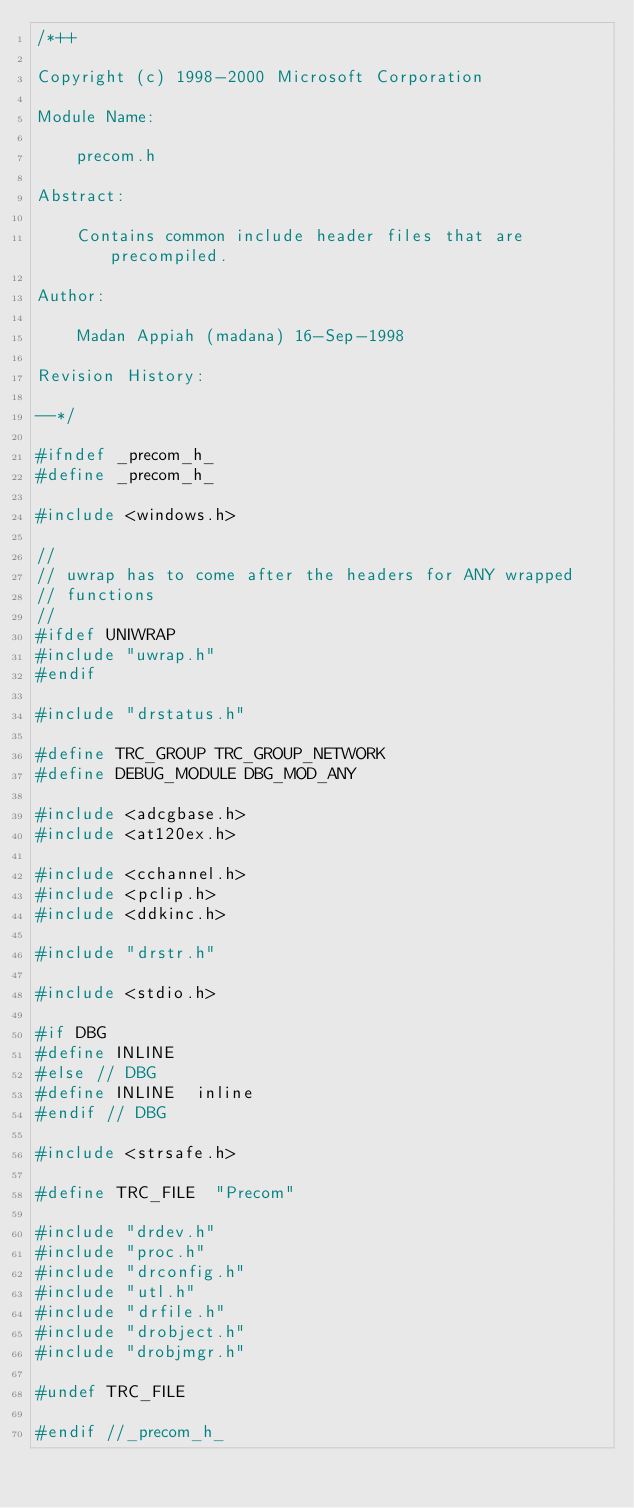<code> <loc_0><loc_0><loc_500><loc_500><_C_>/*++

Copyright (c) 1998-2000 Microsoft Corporation

Module Name:

    precom.h

Abstract:

    Contains common include header files that are precompiled.

Author:

    Madan Appiah (madana) 16-Sep-1998

Revision History:

--*/

#ifndef _precom_h_
#define _precom_h_

#include <windows.h>

//
// uwrap has to come after the headers for ANY wrapped
// functions
//
#ifdef UNIWRAP
#include "uwrap.h"
#endif

#include "drstatus.h"

#define TRC_GROUP TRC_GROUP_NETWORK
#define DEBUG_MODULE DBG_MOD_ANY

#include <adcgbase.h>
#include <at120ex.h>

#include <cchannel.h>
#include <pclip.h>
#include <ddkinc.h>

#include "drstr.h"

#include <stdio.h>

#if DBG
#define INLINE
#else // DBG
#define INLINE  inline
#endif // DBG

#include <strsafe.h>

#define TRC_FILE  "Precom"

#include "drdev.h"
#include "proc.h"
#include "drconfig.h"
#include "utl.h"
#include "drfile.h"
#include "drobject.h"
#include "drobjmgr.h"

#undef TRC_FILE

#endif //_precom_h_


</code> 